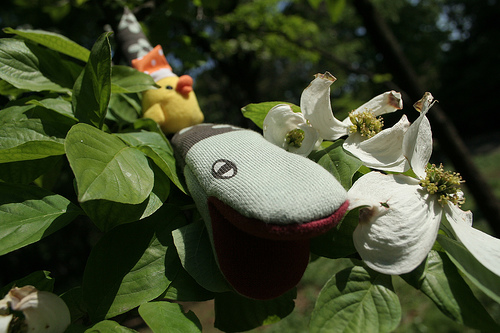<image>
Can you confirm if the puppet is on the leaves? Yes. Looking at the image, I can see the puppet is positioned on top of the leaves, with the leaves providing support. 